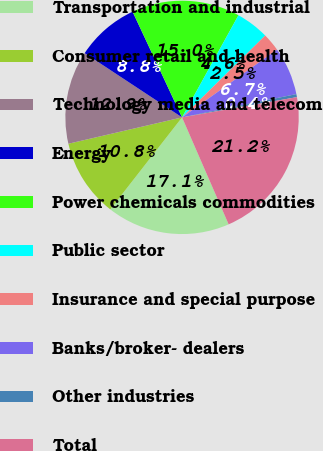Convert chart to OTSL. <chart><loc_0><loc_0><loc_500><loc_500><pie_chart><fcel>Transportation and industrial<fcel>Consumer retail and health<fcel>Technology media and telecom<fcel>Energy<fcel>Power chemicals commodities<fcel>Public sector<fcel>Insurance and special purpose<fcel>Banks/broker- dealers<fcel>Other industries<fcel>Total<nl><fcel>17.08%<fcel>10.83%<fcel>12.91%<fcel>8.75%<fcel>15.0%<fcel>4.59%<fcel>2.51%<fcel>6.67%<fcel>0.42%<fcel>21.24%<nl></chart> 